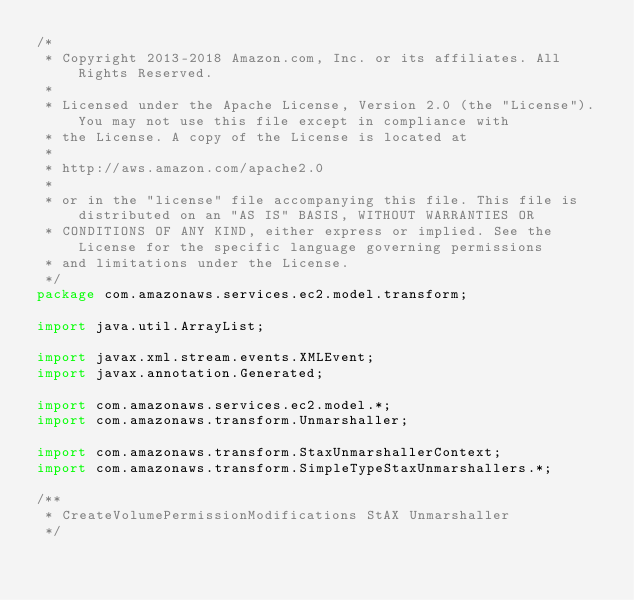<code> <loc_0><loc_0><loc_500><loc_500><_Java_>/*
 * Copyright 2013-2018 Amazon.com, Inc. or its affiliates. All Rights Reserved.
 * 
 * Licensed under the Apache License, Version 2.0 (the "License"). You may not use this file except in compliance with
 * the License. A copy of the License is located at
 * 
 * http://aws.amazon.com/apache2.0
 * 
 * or in the "license" file accompanying this file. This file is distributed on an "AS IS" BASIS, WITHOUT WARRANTIES OR
 * CONDITIONS OF ANY KIND, either express or implied. See the License for the specific language governing permissions
 * and limitations under the License.
 */
package com.amazonaws.services.ec2.model.transform;

import java.util.ArrayList;

import javax.xml.stream.events.XMLEvent;
import javax.annotation.Generated;

import com.amazonaws.services.ec2.model.*;
import com.amazonaws.transform.Unmarshaller;

import com.amazonaws.transform.StaxUnmarshallerContext;
import com.amazonaws.transform.SimpleTypeStaxUnmarshallers.*;

/**
 * CreateVolumePermissionModifications StAX Unmarshaller
 */
</code> 